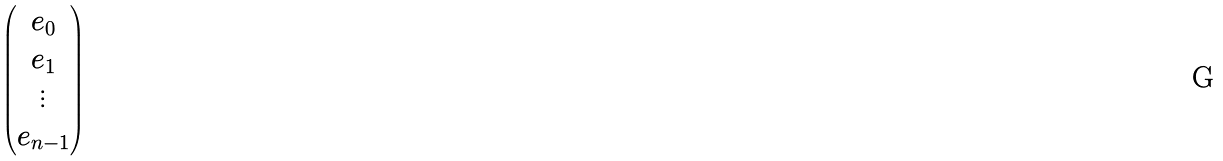<formula> <loc_0><loc_0><loc_500><loc_500>\begin{pmatrix} e _ { 0 } \\ e _ { 1 } \\ \vdots \\ e _ { n - 1 } \end{pmatrix}</formula> 